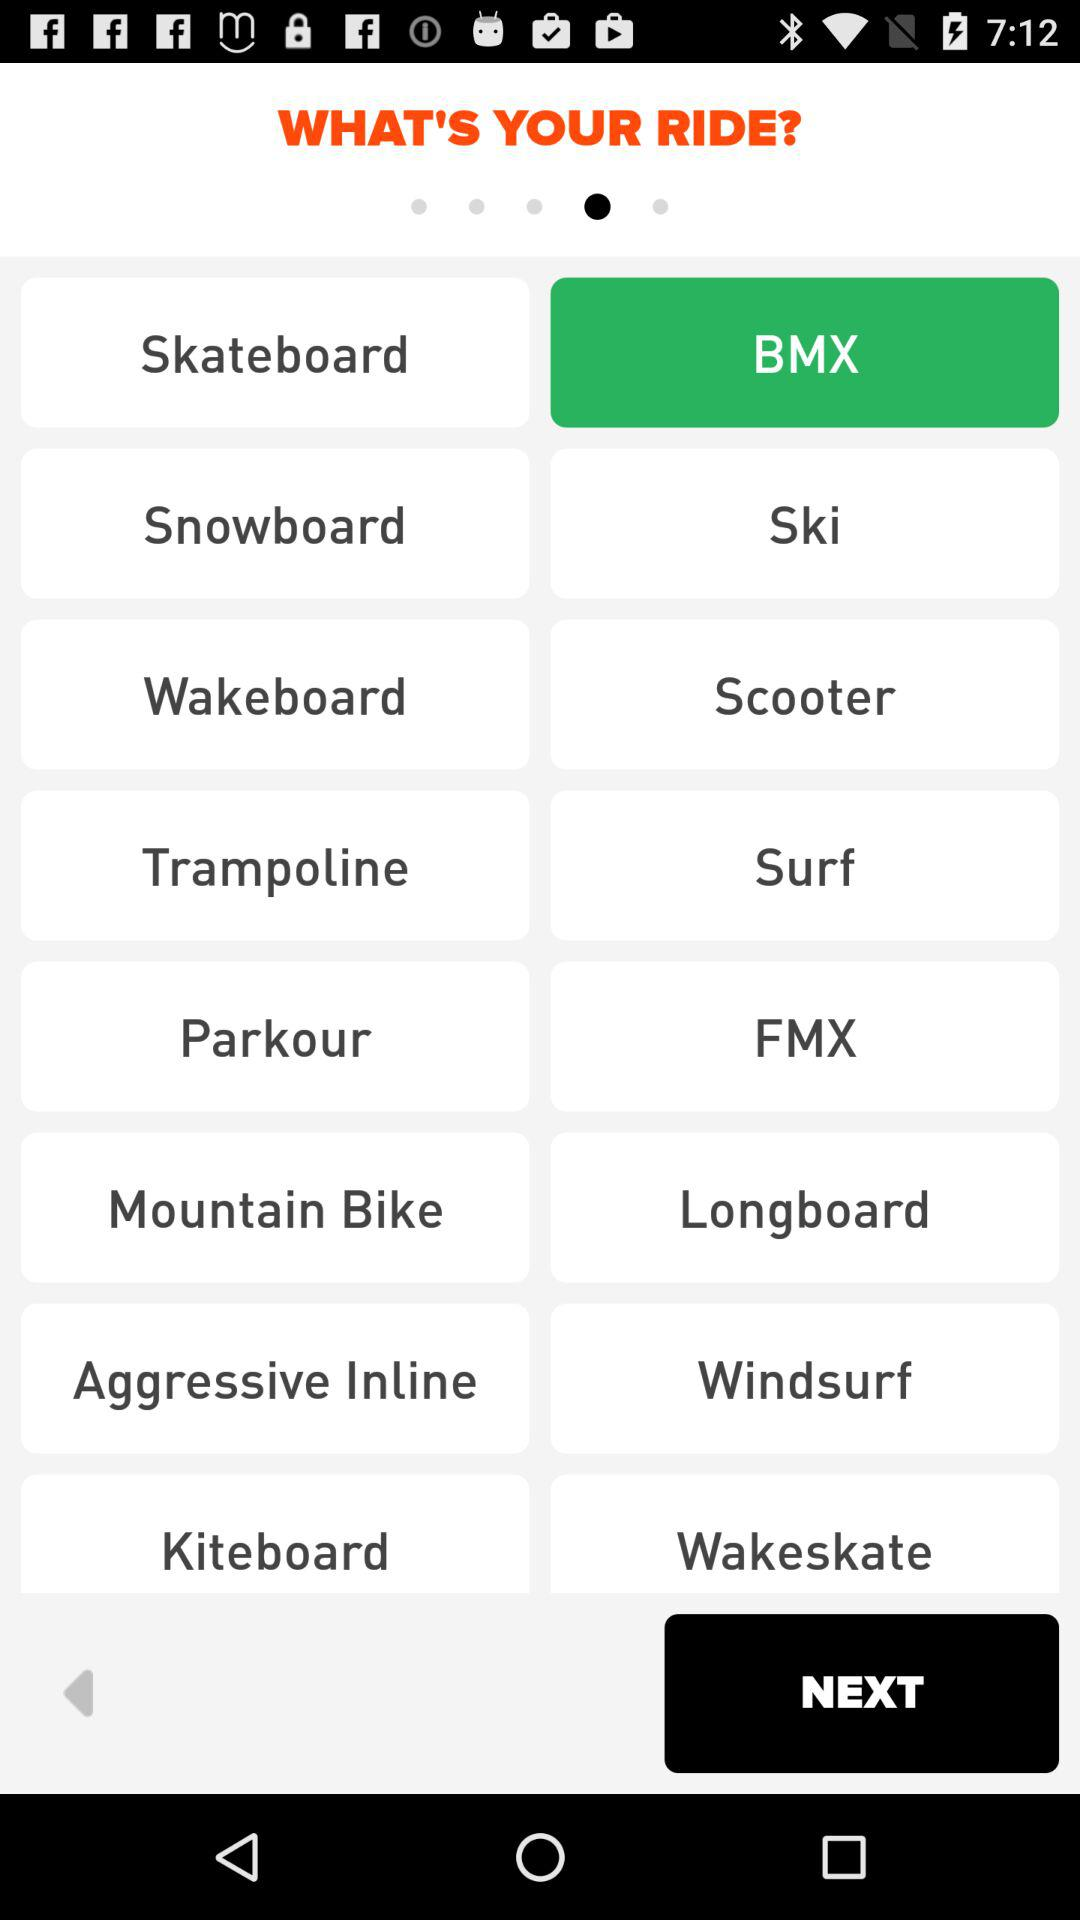What ride is selected? The selected ride is BMX. 